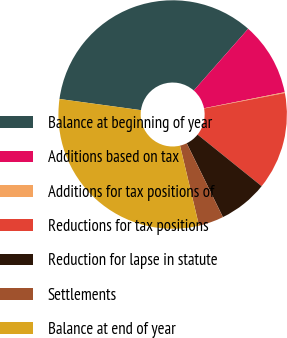Convert chart. <chart><loc_0><loc_0><loc_500><loc_500><pie_chart><fcel>Balance at beginning of year<fcel>Additions based on tax<fcel>Additions for tax positions of<fcel>Reductions for tax positions<fcel>Reduction for lapse in statute<fcel>Settlements<fcel>Balance at end of year<nl><fcel>34.32%<fcel>10.38%<fcel>0.12%<fcel>13.8%<fcel>6.96%<fcel>3.54%<fcel>30.88%<nl></chart> 